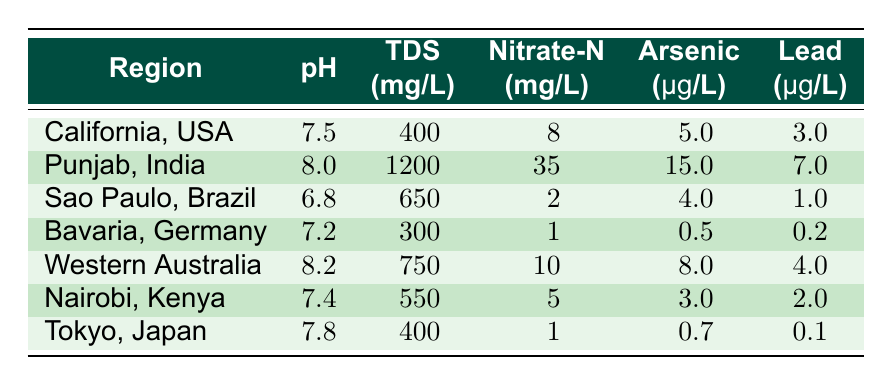What is the pH of the groundwater in Punjab, India? The table shows the pH values for different regions. For Punjab, India, the pH is listed as 8.0.
Answer: 8.0 Which region has the highest concentration of Nitrate-N? Looking through the Nitrate-N column, Punjab, India has the highest value of 35 mg/L.
Answer: Punjab, India What is the average Total Dissolved Solids (TDS) for the regions listed? Summing the TDS values: 400 + 1200 + 650 + 300 + 750 + 550 + 400 = 3950 mg/L. There are 7 regions, so the average is 3950 / 7 = 564.29 mg/L.
Answer: 564.29 Is the amount of Arsenic in Sao Paulo, Brazil greater than 5 µg/L? In the table, the Arsenic level for Sao Paulo is 4 µg/L, which is less than 5 µg/L, so the answer is false.
Answer: No Which region has the lowest Lead levels and what is that value? By reviewing the Lead column, Bavaria, Germany has the lowest Lead concentration at 0.2 µg/L.
Answer: 0.2 µg/L What is the difference in pH between Western Australia and Bavaria, Germany? The pH for Western Australia is 8.2 and for Bavaria is 7.2. The difference is calculated as 8.2 - 7.2 = 1.0.
Answer: 1.0 Are there any regions where the Total Dissolved Solids are below 500 mg/L? The table lists TDS values, and the only region with TDS below 500 mg/L is Bavaria, Germany at 300 mg/L. Hence, the answer is yes.
Answer: Yes Which region has both the highest Nitrate-N and the highest Arsenic levels? Punjab, India has the highest Nitrate-N at 35 mg/L and also has the highest Arsenic level at 15 µg/L. Therefore, Punjab is the region that meets both criteria.
Answer: Punjab, India What percentage of the total Nitrate-N does California contribute compared to the sum of Nitrate-N in all regions? The total Nitrate-N across all regions is 8 + 35 + 2 + 1 + 10 + 5 + 1 = 62 mg/L. California contributes 8 mg/L, so the percentage is (8 / 62) * 100 = 12.90%.
Answer: 12.90% 